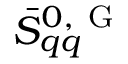<formula> <loc_0><loc_0><loc_500><loc_500>\bar { S } _ { q q } ^ { 0 , G }</formula> 